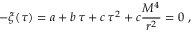<formula> <loc_0><loc_0><loc_500><loc_500>- \xi ( \tau ) = a + b \, \tau + c \, \tau ^ { 2 } + c \frac { M ^ { 4 } } { r ^ { 2 } } = 0 \ ,</formula> 